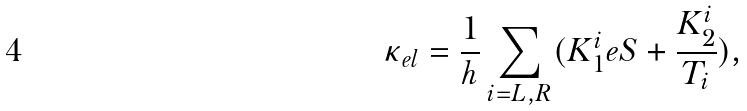Convert formula to latex. <formula><loc_0><loc_0><loc_500><loc_500>\kappa _ { e l } = \frac { 1 } { h } \sum _ { i = L , R } ( K _ { 1 } ^ { i } e S + \frac { K _ { 2 } ^ { i } } { T _ { i } } ) ,</formula> 